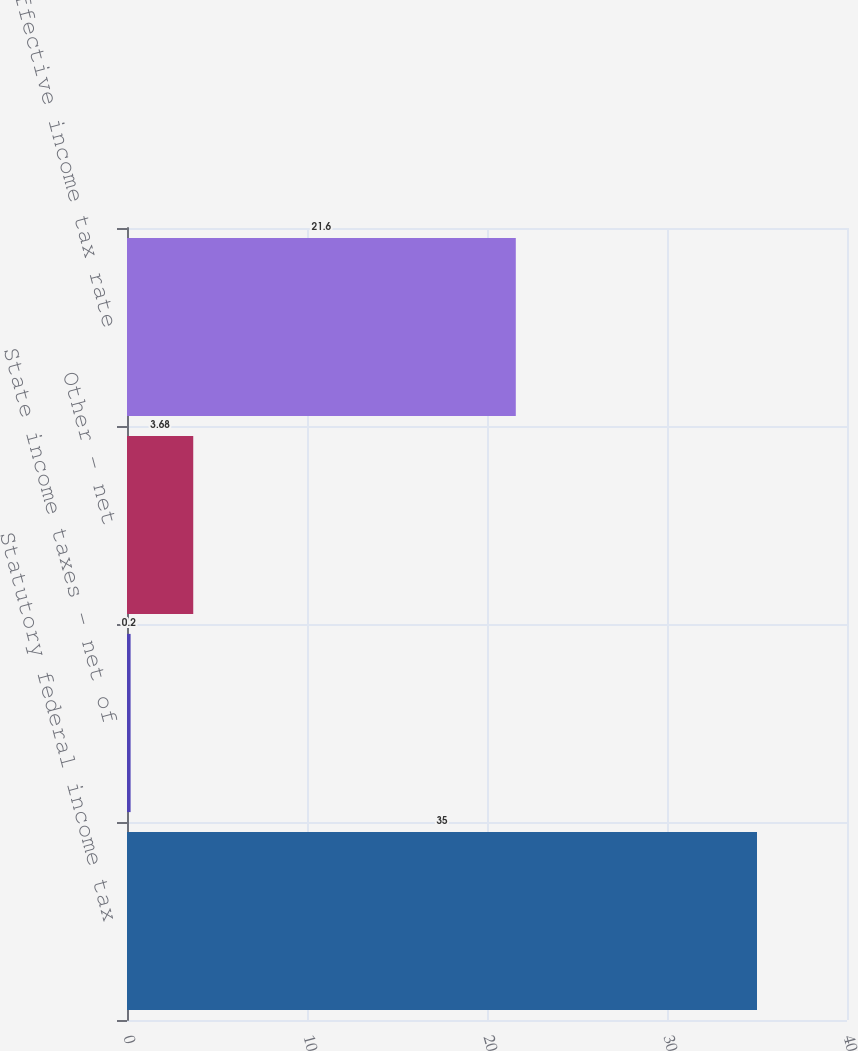Convert chart to OTSL. <chart><loc_0><loc_0><loc_500><loc_500><bar_chart><fcel>Statutory federal income tax<fcel>State income taxes - net of<fcel>Other - net<fcel>Effective income tax rate<nl><fcel>35<fcel>0.2<fcel>3.68<fcel>21.6<nl></chart> 